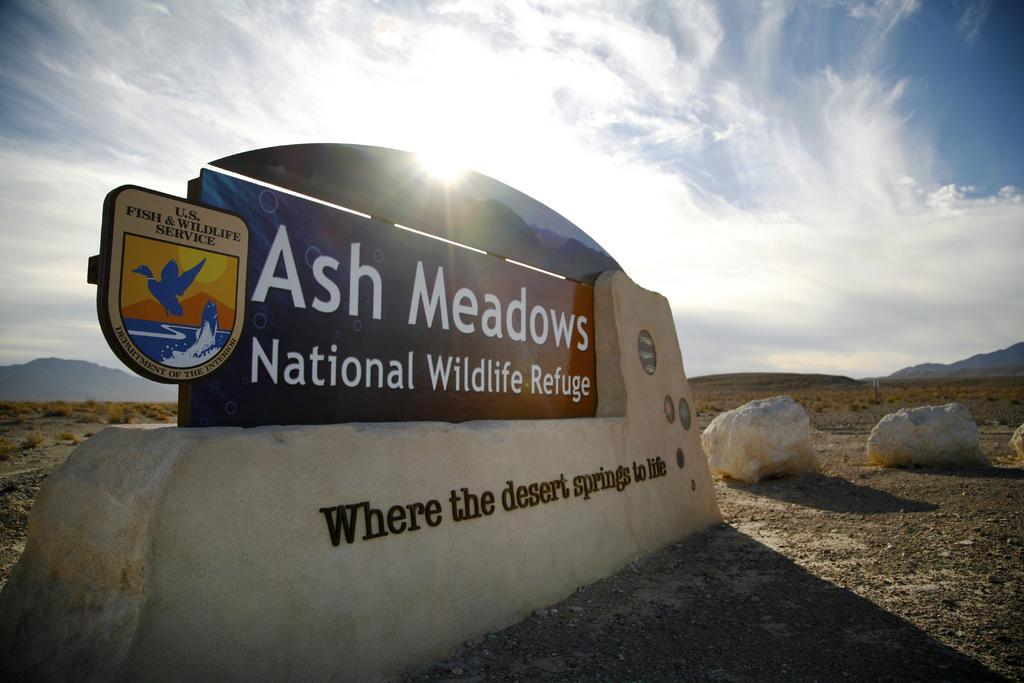Describe this image in one or two sentences. In this image we can see a board with some text written on it. Behind land is there and the sky is in blue color with some clouds and sun. 